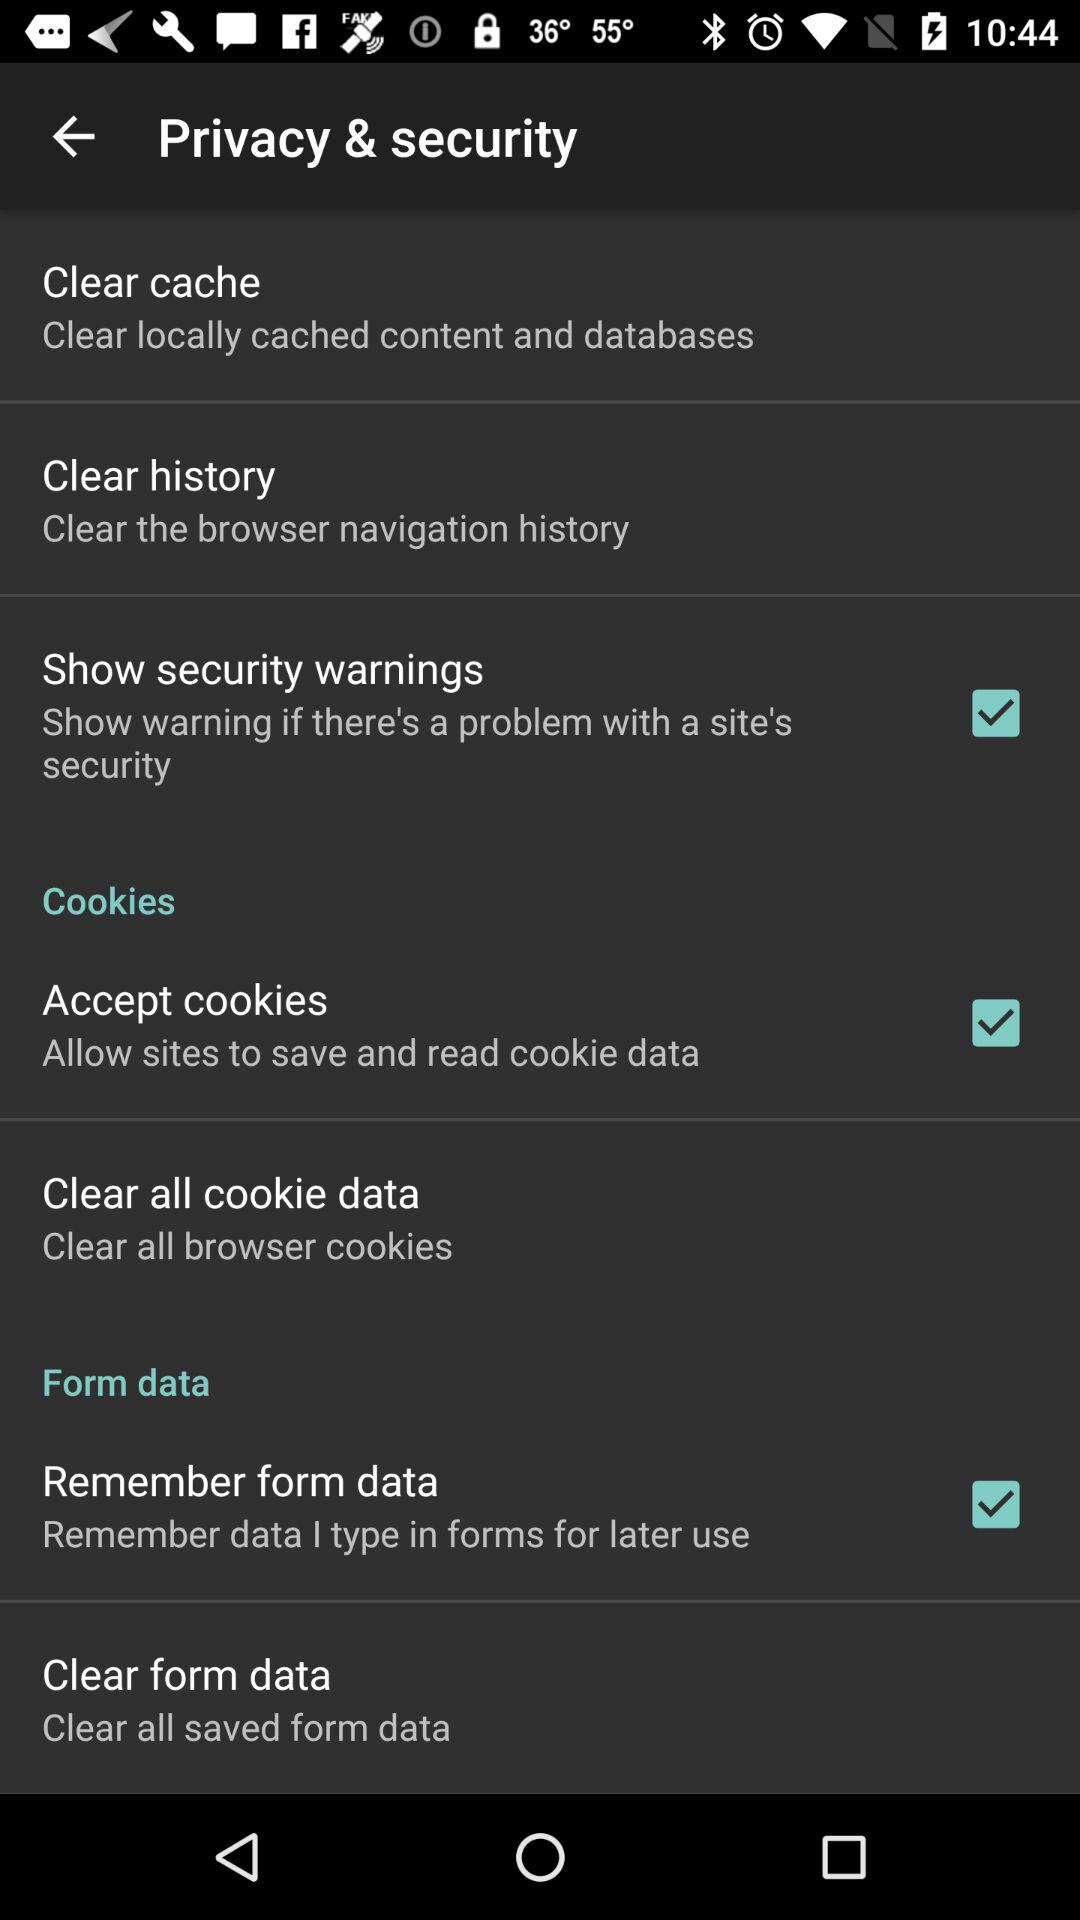How many items in the 'Privacy & security' menu have a checkbox?
Answer the question using a single word or phrase. 3 